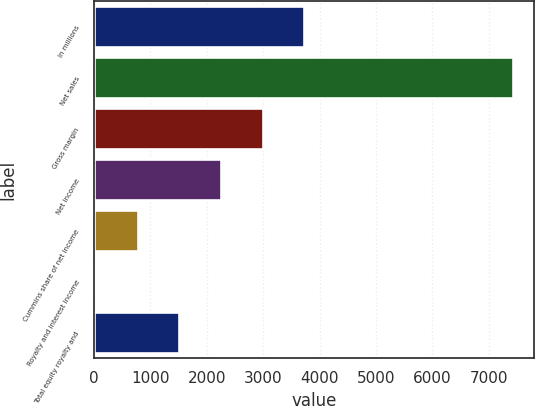<chart> <loc_0><loc_0><loc_500><loc_500><bar_chart><fcel>In millions<fcel>Net sales<fcel>Gross margin<fcel>Net income<fcel>Cummins share of net income<fcel>Royalty and interest income<fcel>Total equity royalty and<nl><fcel>3733<fcel>7426<fcel>2994.4<fcel>2255.8<fcel>778.6<fcel>40<fcel>1517.2<nl></chart> 